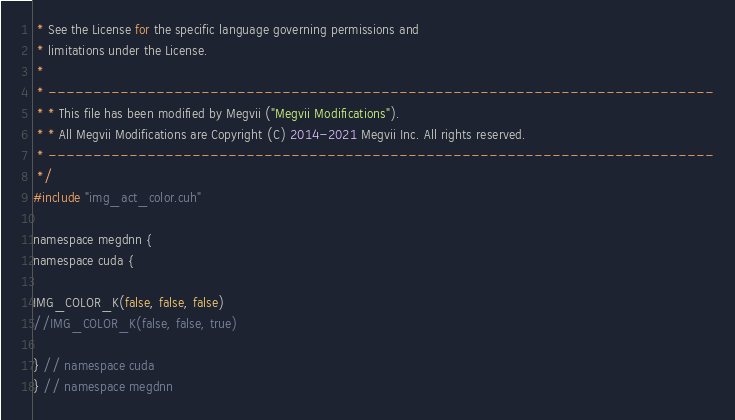<code> <loc_0><loc_0><loc_500><loc_500><_Cuda_> * See the License for the specific language governing permissions and
 * limitations under the License.
 *
 * --------------------------------------------------------------------------
 * * This file has been modified by Megvii ("Megvii Modifications").
 * * All Megvii Modifications are Copyright (C) 2014-2021 Megvii Inc. All rights reserved.
 * --------------------------------------------------------------------------
 */
#include "img_act_color.cuh"

namespace megdnn {
namespace cuda {

IMG_COLOR_K(false, false, false)
//IMG_COLOR_K(false, false, true)

} // namespace cuda
} // namespace megdnn
</code> 